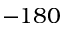Convert formula to latex. <formula><loc_0><loc_0><loc_500><loc_500>- 1 8 0</formula> 